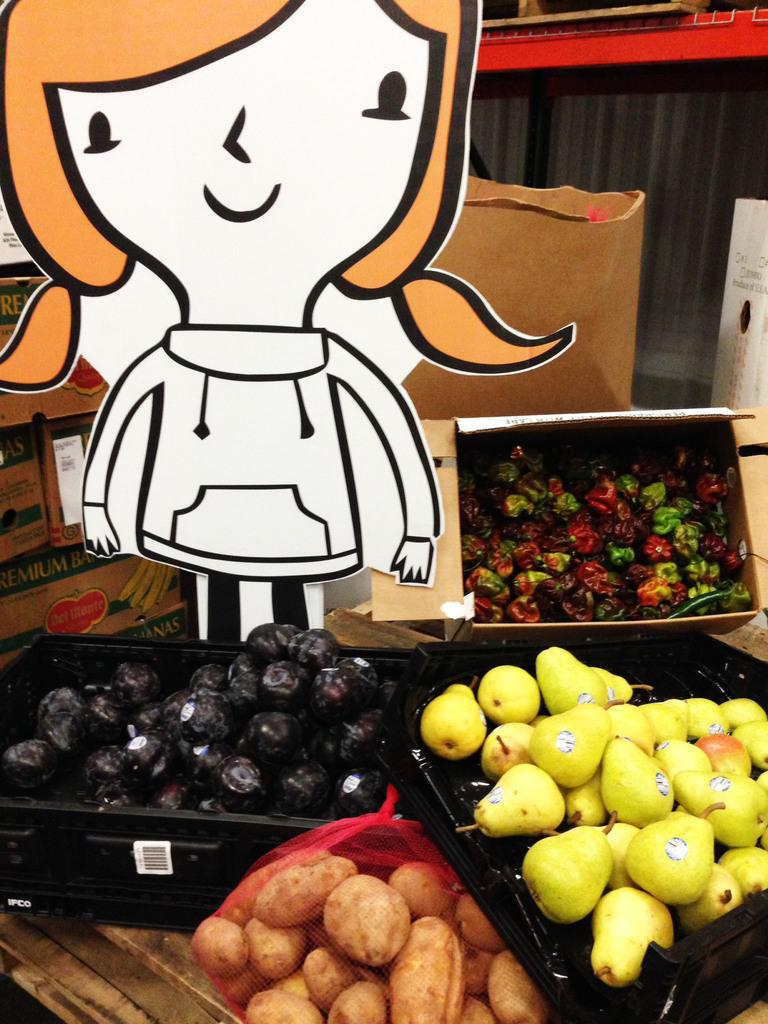What objects are present in the image that can hold items? There are trays in the image. What is on the trays in the image? The trays contain fruits. Can you describe any additional visual elements in the image? There is a cartoon character visible in the image. What type of arch can be seen in the background of the image? There is no arch present in the image. What meal is being served on the trays in the image? The image does not specify a meal, but it shows trays containing fruits. 